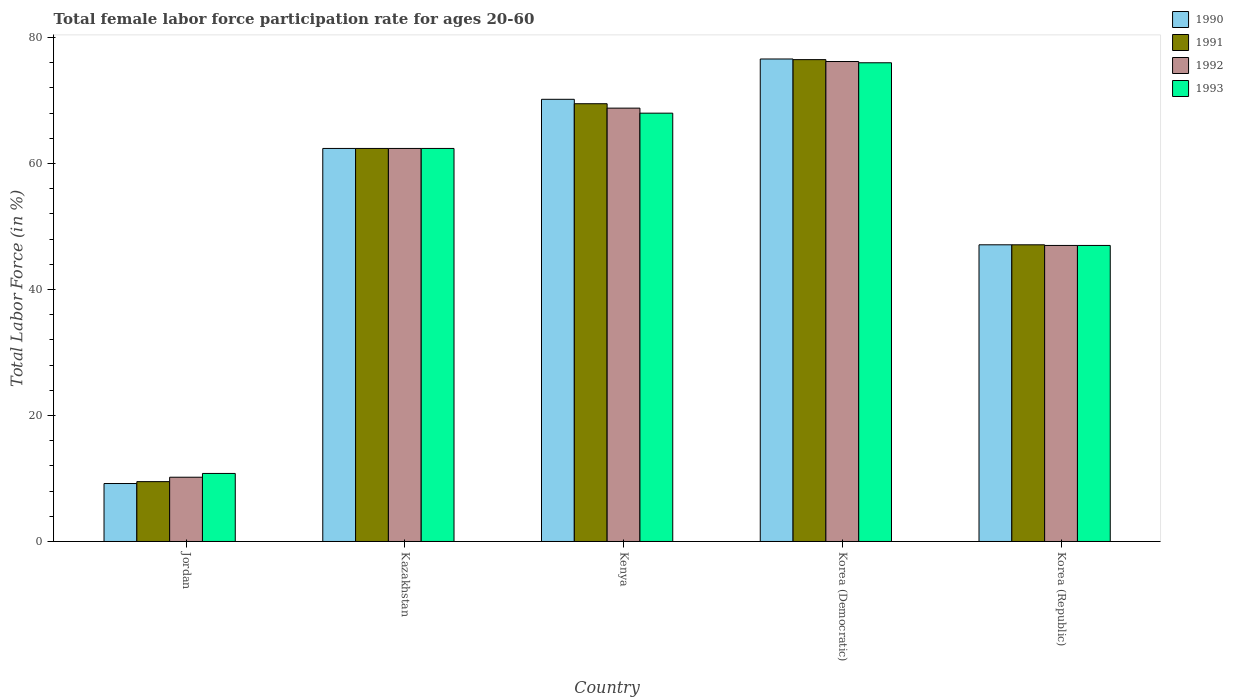How many different coloured bars are there?
Your response must be concise. 4. How many groups of bars are there?
Offer a very short reply. 5. Are the number of bars per tick equal to the number of legend labels?
Offer a terse response. Yes. Are the number of bars on each tick of the X-axis equal?
Provide a short and direct response. Yes. How many bars are there on the 1st tick from the left?
Keep it short and to the point. 4. How many bars are there on the 1st tick from the right?
Your response must be concise. 4. What is the label of the 4th group of bars from the left?
Provide a succinct answer. Korea (Democratic). What is the female labor force participation rate in 1991 in Kazakhstan?
Ensure brevity in your answer.  62.4. Across all countries, what is the maximum female labor force participation rate in 1991?
Keep it short and to the point. 76.5. Across all countries, what is the minimum female labor force participation rate in 1992?
Offer a terse response. 10.2. In which country was the female labor force participation rate in 1992 maximum?
Offer a terse response. Korea (Democratic). In which country was the female labor force participation rate in 1992 minimum?
Provide a succinct answer. Jordan. What is the total female labor force participation rate in 1993 in the graph?
Make the answer very short. 264.2. What is the difference between the female labor force participation rate in 1992 in Jordan and that in Kenya?
Offer a terse response. -58.6. What is the difference between the female labor force participation rate in 1991 in Korea (Republic) and the female labor force participation rate in 1990 in Kazakhstan?
Offer a very short reply. -15.3. What is the average female labor force participation rate in 1990 per country?
Provide a short and direct response. 53.1. What is the difference between the female labor force participation rate of/in 1990 and female labor force participation rate of/in 1991 in Jordan?
Your answer should be very brief. -0.3. What is the ratio of the female labor force participation rate in 1991 in Kenya to that in Korea (Democratic)?
Your answer should be compact. 0.91. Is the difference between the female labor force participation rate in 1990 in Jordan and Korea (Republic) greater than the difference between the female labor force participation rate in 1991 in Jordan and Korea (Republic)?
Make the answer very short. No. What is the difference between the highest and the second highest female labor force participation rate in 1991?
Ensure brevity in your answer.  7. What is the difference between the highest and the lowest female labor force participation rate in 1993?
Make the answer very short. 65.2. In how many countries, is the female labor force participation rate in 1992 greater than the average female labor force participation rate in 1992 taken over all countries?
Your answer should be compact. 3. Is it the case that in every country, the sum of the female labor force participation rate in 1992 and female labor force participation rate in 1991 is greater than the sum of female labor force participation rate in 1993 and female labor force participation rate in 1990?
Your answer should be very brief. No. What does the 2nd bar from the left in Jordan represents?
Keep it short and to the point. 1991. What does the 3rd bar from the right in Kenya represents?
Give a very brief answer. 1991. What is the difference between two consecutive major ticks on the Y-axis?
Your response must be concise. 20. Does the graph contain any zero values?
Make the answer very short. No. Does the graph contain grids?
Make the answer very short. No. How many legend labels are there?
Give a very brief answer. 4. How are the legend labels stacked?
Offer a very short reply. Vertical. What is the title of the graph?
Keep it short and to the point. Total female labor force participation rate for ages 20-60. Does "1992" appear as one of the legend labels in the graph?
Offer a terse response. Yes. What is the label or title of the Y-axis?
Provide a short and direct response. Total Labor Force (in %). What is the Total Labor Force (in %) in 1990 in Jordan?
Your answer should be very brief. 9.2. What is the Total Labor Force (in %) in 1992 in Jordan?
Your response must be concise. 10.2. What is the Total Labor Force (in %) in 1993 in Jordan?
Ensure brevity in your answer.  10.8. What is the Total Labor Force (in %) in 1990 in Kazakhstan?
Offer a very short reply. 62.4. What is the Total Labor Force (in %) of 1991 in Kazakhstan?
Keep it short and to the point. 62.4. What is the Total Labor Force (in %) in 1992 in Kazakhstan?
Provide a succinct answer. 62.4. What is the Total Labor Force (in %) in 1993 in Kazakhstan?
Your response must be concise. 62.4. What is the Total Labor Force (in %) in 1990 in Kenya?
Make the answer very short. 70.2. What is the Total Labor Force (in %) of 1991 in Kenya?
Your answer should be compact. 69.5. What is the Total Labor Force (in %) in 1992 in Kenya?
Provide a succinct answer. 68.8. What is the Total Labor Force (in %) in 1990 in Korea (Democratic)?
Ensure brevity in your answer.  76.6. What is the Total Labor Force (in %) of 1991 in Korea (Democratic)?
Offer a terse response. 76.5. What is the Total Labor Force (in %) in 1992 in Korea (Democratic)?
Give a very brief answer. 76.2. What is the Total Labor Force (in %) of 1993 in Korea (Democratic)?
Give a very brief answer. 76. What is the Total Labor Force (in %) of 1990 in Korea (Republic)?
Offer a terse response. 47.1. What is the Total Labor Force (in %) of 1991 in Korea (Republic)?
Offer a terse response. 47.1. Across all countries, what is the maximum Total Labor Force (in %) of 1990?
Provide a short and direct response. 76.6. Across all countries, what is the maximum Total Labor Force (in %) of 1991?
Give a very brief answer. 76.5. Across all countries, what is the maximum Total Labor Force (in %) of 1992?
Give a very brief answer. 76.2. Across all countries, what is the maximum Total Labor Force (in %) of 1993?
Your answer should be very brief. 76. Across all countries, what is the minimum Total Labor Force (in %) of 1990?
Your response must be concise. 9.2. Across all countries, what is the minimum Total Labor Force (in %) in 1992?
Your answer should be compact. 10.2. Across all countries, what is the minimum Total Labor Force (in %) of 1993?
Provide a succinct answer. 10.8. What is the total Total Labor Force (in %) of 1990 in the graph?
Provide a succinct answer. 265.5. What is the total Total Labor Force (in %) in 1991 in the graph?
Your answer should be very brief. 265. What is the total Total Labor Force (in %) in 1992 in the graph?
Your response must be concise. 264.6. What is the total Total Labor Force (in %) in 1993 in the graph?
Offer a very short reply. 264.2. What is the difference between the Total Labor Force (in %) in 1990 in Jordan and that in Kazakhstan?
Your answer should be very brief. -53.2. What is the difference between the Total Labor Force (in %) in 1991 in Jordan and that in Kazakhstan?
Your response must be concise. -52.9. What is the difference between the Total Labor Force (in %) in 1992 in Jordan and that in Kazakhstan?
Provide a short and direct response. -52.2. What is the difference between the Total Labor Force (in %) of 1993 in Jordan and that in Kazakhstan?
Keep it short and to the point. -51.6. What is the difference between the Total Labor Force (in %) in 1990 in Jordan and that in Kenya?
Give a very brief answer. -61. What is the difference between the Total Labor Force (in %) in 1991 in Jordan and that in Kenya?
Provide a short and direct response. -60. What is the difference between the Total Labor Force (in %) of 1992 in Jordan and that in Kenya?
Your answer should be compact. -58.6. What is the difference between the Total Labor Force (in %) of 1993 in Jordan and that in Kenya?
Your answer should be very brief. -57.2. What is the difference between the Total Labor Force (in %) in 1990 in Jordan and that in Korea (Democratic)?
Offer a terse response. -67.4. What is the difference between the Total Labor Force (in %) of 1991 in Jordan and that in Korea (Democratic)?
Your answer should be very brief. -67. What is the difference between the Total Labor Force (in %) in 1992 in Jordan and that in Korea (Democratic)?
Provide a succinct answer. -66. What is the difference between the Total Labor Force (in %) in 1993 in Jordan and that in Korea (Democratic)?
Give a very brief answer. -65.2. What is the difference between the Total Labor Force (in %) of 1990 in Jordan and that in Korea (Republic)?
Provide a short and direct response. -37.9. What is the difference between the Total Labor Force (in %) of 1991 in Jordan and that in Korea (Republic)?
Ensure brevity in your answer.  -37.6. What is the difference between the Total Labor Force (in %) of 1992 in Jordan and that in Korea (Republic)?
Make the answer very short. -36.8. What is the difference between the Total Labor Force (in %) of 1993 in Jordan and that in Korea (Republic)?
Provide a short and direct response. -36.2. What is the difference between the Total Labor Force (in %) of 1993 in Kazakhstan and that in Kenya?
Make the answer very short. -5.6. What is the difference between the Total Labor Force (in %) of 1991 in Kazakhstan and that in Korea (Democratic)?
Offer a very short reply. -14.1. What is the difference between the Total Labor Force (in %) in 1992 in Kazakhstan and that in Korea (Democratic)?
Give a very brief answer. -13.8. What is the difference between the Total Labor Force (in %) in 1993 in Kazakhstan and that in Korea (Democratic)?
Offer a very short reply. -13.6. What is the difference between the Total Labor Force (in %) in 1990 in Kazakhstan and that in Korea (Republic)?
Give a very brief answer. 15.3. What is the difference between the Total Labor Force (in %) of 1993 in Kazakhstan and that in Korea (Republic)?
Give a very brief answer. 15.4. What is the difference between the Total Labor Force (in %) of 1990 in Kenya and that in Korea (Democratic)?
Your answer should be very brief. -6.4. What is the difference between the Total Labor Force (in %) of 1993 in Kenya and that in Korea (Democratic)?
Give a very brief answer. -8. What is the difference between the Total Labor Force (in %) in 1990 in Kenya and that in Korea (Republic)?
Provide a short and direct response. 23.1. What is the difference between the Total Labor Force (in %) of 1991 in Kenya and that in Korea (Republic)?
Provide a short and direct response. 22.4. What is the difference between the Total Labor Force (in %) in 1992 in Kenya and that in Korea (Republic)?
Your answer should be compact. 21.8. What is the difference between the Total Labor Force (in %) in 1990 in Korea (Democratic) and that in Korea (Republic)?
Make the answer very short. 29.5. What is the difference between the Total Labor Force (in %) in 1991 in Korea (Democratic) and that in Korea (Republic)?
Provide a succinct answer. 29.4. What is the difference between the Total Labor Force (in %) of 1992 in Korea (Democratic) and that in Korea (Republic)?
Your response must be concise. 29.2. What is the difference between the Total Labor Force (in %) of 1993 in Korea (Democratic) and that in Korea (Republic)?
Provide a succinct answer. 29. What is the difference between the Total Labor Force (in %) in 1990 in Jordan and the Total Labor Force (in %) in 1991 in Kazakhstan?
Keep it short and to the point. -53.2. What is the difference between the Total Labor Force (in %) of 1990 in Jordan and the Total Labor Force (in %) of 1992 in Kazakhstan?
Make the answer very short. -53.2. What is the difference between the Total Labor Force (in %) in 1990 in Jordan and the Total Labor Force (in %) in 1993 in Kazakhstan?
Offer a terse response. -53.2. What is the difference between the Total Labor Force (in %) in 1991 in Jordan and the Total Labor Force (in %) in 1992 in Kazakhstan?
Provide a short and direct response. -52.9. What is the difference between the Total Labor Force (in %) in 1991 in Jordan and the Total Labor Force (in %) in 1993 in Kazakhstan?
Provide a short and direct response. -52.9. What is the difference between the Total Labor Force (in %) of 1992 in Jordan and the Total Labor Force (in %) of 1993 in Kazakhstan?
Give a very brief answer. -52.2. What is the difference between the Total Labor Force (in %) in 1990 in Jordan and the Total Labor Force (in %) in 1991 in Kenya?
Make the answer very short. -60.3. What is the difference between the Total Labor Force (in %) in 1990 in Jordan and the Total Labor Force (in %) in 1992 in Kenya?
Offer a terse response. -59.6. What is the difference between the Total Labor Force (in %) of 1990 in Jordan and the Total Labor Force (in %) of 1993 in Kenya?
Provide a short and direct response. -58.8. What is the difference between the Total Labor Force (in %) in 1991 in Jordan and the Total Labor Force (in %) in 1992 in Kenya?
Your answer should be very brief. -59.3. What is the difference between the Total Labor Force (in %) of 1991 in Jordan and the Total Labor Force (in %) of 1993 in Kenya?
Provide a succinct answer. -58.5. What is the difference between the Total Labor Force (in %) of 1992 in Jordan and the Total Labor Force (in %) of 1993 in Kenya?
Make the answer very short. -57.8. What is the difference between the Total Labor Force (in %) of 1990 in Jordan and the Total Labor Force (in %) of 1991 in Korea (Democratic)?
Ensure brevity in your answer.  -67.3. What is the difference between the Total Labor Force (in %) of 1990 in Jordan and the Total Labor Force (in %) of 1992 in Korea (Democratic)?
Keep it short and to the point. -67. What is the difference between the Total Labor Force (in %) in 1990 in Jordan and the Total Labor Force (in %) in 1993 in Korea (Democratic)?
Provide a succinct answer. -66.8. What is the difference between the Total Labor Force (in %) of 1991 in Jordan and the Total Labor Force (in %) of 1992 in Korea (Democratic)?
Offer a very short reply. -66.7. What is the difference between the Total Labor Force (in %) in 1991 in Jordan and the Total Labor Force (in %) in 1993 in Korea (Democratic)?
Give a very brief answer. -66.5. What is the difference between the Total Labor Force (in %) of 1992 in Jordan and the Total Labor Force (in %) of 1993 in Korea (Democratic)?
Your answer should be very brief. -65.8. What is the difference between the Total Labor Force (in %) of 1990 in Jordan and the Total Labor Force (in %) of 1991 in Korea (Republic)?
Your answer should be compact. -37.9. What is the difference between the Total Labor Force (in %) of 1990 in Jordan and the Total Labor Force (in %) of 1992 in Korea (Republic)?
Keep it short and to the point. -37.8. What is the difference between the Total Labor Force (in %) in 1990 in Jordan and the Total Labor Force (in %) in 1993 in Korea (Republic)?
Make the answer very short. -37.8. What is the difference between the Total Labor Force (in %) in 1991 in Jordan and the Total Labor Force (in %) in 1992 in Korea (Republic)?
Give a very brief answer. -37.5. What is the difference between the Total Labor Force (in %) in 1991 in Jordan and the Total Labor Force (in %) in 1993 in Korea (Republic)?
Provide a succinct answer. -37.5. What is the difference between the Total Labor Force (in %) in 1992 in Jordan and the Total Labor Force (in %) in 1993 in Korea (Republic)?
Your response must be concise. -36.8. What is the difference between the Total Labor Force (in %) of 1990 in Kazakhstan and the Total Labor Force (in %) of 1992 in Kenya?
Ensure brevity in your answer.  -6.4. What is the difference between the Total Labor Force (in %) of 1991 in Kazakhstan and the Total Labor Force (in %) of 1992 in Kenya?
Ensure brevity in your answer.  -6.4. What is the difference between the Total Labor Force (in %) in 1991 in Kazakhstan and the Total Labor Force (in %) in 1993 in Kenya?
Provide a short and direct response. -5.6. What is the difference between the Total Labor Force (in %) in 1992 in Kazakhstan and the Total Labor Force (in %) in 1993 in Kenya?
Ensure brevity in your answer.  -5.6. What is the difference between the Total Labor Force (in %) of 1990 in Kazakhstan and the Total Labor Force (in %) of 1991 in Korea (Democratic)?
Make the answer very short. -14.1. What is the difference between the Total Labor Force (in %) of 1991 in Kazakhstan and the Total Labor Force (in %) of 1993 in Korea (Democratic)?
Your response must be concise. -13.6. What is the difference between the Total Labor Force (in %) in 1990 in Kazakhstan and the Total Labor Force (in %) in 1991 in Korea (Republic)?
Give a very brief answer. 15.3. What is the difference between the Total Labor Force (in %) of 1992 in Kazakhstan and the Total Labor Force (in %) of 1993 in Korea (Republic)?
Your answer should be compact. 15.4. What is the difference between the Total Labor Force (in %) in 1990 in Kenya and the Total Labor Force (in %) in 1991 in Korea (Democratic)?
Provide a succinct answer. -6.3. What is the difference between the Total Labor Force (in %) of 1990 in Kenya and the Total Labor Force (in %) of 1992 in Korea (Democratic)?
Your answer should be compact. -6. What is the difference between the Total Labor Force (in %) of 1991 in Kenya and the Total Labor Force (in %) of 1992 in Korea (Democratic)?
Your answer should be very brief. -6.7. What is the difference between the Total Labor Force (in %) of 1992 in Kenya and the Total Labor Force (in %) of 1993 in Korea (Democratic)?
Your response must be concise. -7.2. What is the difference between the Total Labor Force (in %) in 1990 in Kenya and the Total Labor Force (in %) in 1991 in Korea (Republic)?
Offer a terse response. 23.1. What is the difference between the Total Labor Force (in %) in 1990 in Kenya and the Total Labor Force (in %) in 1992 in Korea (Republic)?
Your response must be concise. 23.2. What is the difference between the Total Labor Force (in %) in 1990 in Kenya and the Total Labor Force (in %) in 1993 in Korea (Republic)?
Ensure brevity in your answer.  23.2. What is the difference between the Total Labor Force (in %) of 1991 in Kenya and the Total Labor Force (in %) of 1992 in Korea (Republic)?
Make the answer very short. 22.5. What is the difference between the Total Labor Force (in %) in 1991 in Kenya and the Total Labor Force (in %) in 1993 in Korea (Republic)?
Ensure brevity in your answer.  22.5. What is the difference between the Total Labor Force (in %) in 1992 in Kenya and the Total Labor Force (in %) in 1993 in Korea (Republic)?
Give a very brief answer. 21.8. What is the difference between the Total Labor Force (in %) of 1990 in Korea (Democratic) and the Total Labor Force (in %) of 1991 in Korea (Republic)?
Offer a very short reply. 29.5. What is the difference between the Total Labor Force (in %) in 1990 in Korea (Democratic) and the Total Labor Force (in %) in 1992 in Korea (Republic)?
Ensure brevity in your answer.  29.6. What is the difference between the Total Labor Force (in %) of 1990 in Korea (Democratic) and the Total Labor Force (in %) of 1993 in Korea (Republic)?
Provide a succinct answer. 29.6. What is the difference between the Total Labor Force (in %) of 1991 in Korea (Democratic) and the Total Labor Force (in %) of 1992 in Korea (Republic)?
Ensure brevity in your answer.  29.5. What is the difference between the Total Labor Force (in %) of 1991 in Korea (Democratic) and the Total Labor Force (in %) of 1993 in Korea (Republic)?
Provide a succinct answer. 29.5. What is the difference between the Total Labor Force (in %) in 1992 in Korea (Democratic) and the Total Labor Force (in %) in 1993 in Korea (Republic)?
Your answer should be very brief. 29.2. What is the average Total Labor Force (in %) in 1990 per country?
Ensure brevity in your answer.  53.1. What is the average Total Labor Force (in %) of 1991 per country?
Give a very brief answer. 53. What is the average Total Labor Force (in %) in 1992 per country?
Make the answer very short. 52.92. What is the average Total Labor Force (in %) in 1993 per country?
Provide a succinct answer. 52.84. What is the difference between the Total Labor Force (in %) of 1990 and Total Labor Force (in %) of 1992 in Jordan?
Ensure brevity in your answer.  -1. What is the difference between the Total Labor Force (in %) of 1990 and Total Labor Force (in %) of 1993 in Jordan?
Ensure brevity in your answer.  -1.6. What is the difference between the Total Labor Force (in %) in 1991 and Total Labor Force (in %) in 1992 in Jordan?
Offer a terse response. -0.7. What is the difference between the Total Labor Force (in %) in 1990 and Total Labor Force (in %) in 1991 in Kazakhstan?
Your answer should be compact. 0. What is the difference between the Total Labor Force (in %) of 1990 and Total Labor Force (in %) of 1992 in Kazakhstan?
Your answer should be compact. 0. What is the difference between the Total Labor Force (in %) in 1991 and Total Labor Force (in %) in 1992 in Kazakhstan?
Provide a succinct answer. 0. What is the difference between the Total Labor Force (in %) in 1991 and Total Labor Force (in %) in 1993 in Kazakhstan?
Give a very brief answer. 0. What is the difference between the Total Labor Force (in %) in 1992 and Total Labor Force (in %) in 1993 in Kazakhstan?
Your answer should be compact. 0. What is the difference between the Total Labor Force (in %) in 1990 and Total Labor Force (in %) in 1993 in Kenya?
Offer a terse response. 2.2. What is the difference between the Total Labor Force (in %) in 1991 and Total Labor Force (in %) in 1992 in Kenya?
Offer a very short reply. 0.7. What is the difference between the Total Labor Force (in %) of 1990 and Total Labor Force (in %) of 1992 in Korea (Democratic)?
Give a very brief answer. 0.4. What is the difference between the Total Labor Force (in %) of 1991 and Total Labor Force (in %) of 1993 in Korea (Democratic)?
Provide a short and direct response. 0.5. What is the difference between the Total Labor Force (in %) in 1990 and Total Labor Force (in %) in 1991 in Korea (Republic)?
Provide a succinct answer. 0. What is the difference between the Total Labor Force (in %) of 1990 and Total Labor Force (in %) of 1993 in Korea (Republic)?
Ensure brevity in your answer.  0.1. What is the difference between the Total Labor Force (in %) in 1991 and Total Labor Force (in %) in 1992 in Korea (Republic)?
Offer a very short reply. 0.1. What is the difference between the Total Labor Force (in %) in 1991 and Total Labor Force (in %) in 1993 in Korea (Republic)?
Ensure brevity in your answer.  0.1. What is the difference between the Total Labor Force (in %) of 1992 and Total Labor Force (in %) of 1993 in Korea (Republic)?
Offer a very short reply. 0. What is the ratio of the Total Labor Force (in %) of 1990 in Jordan to that in Kazakhstan?
Offer a terse response. 0.15. What is the ratio of the Total Labor Force (in %) of 1991 in Jordan to that in Kazakhstan?
Give a very brief answer. 0.15. What is the ratio of the Total Labor Force (in %) of 1992 in Jordan to that in Kazakhstan?
Keep it short and to the point. 0.16. What is the ratio of the Total Labor Force (in %) of 1993 in Jordan to that in Kazakhstan?
Ensure brevity in your answer.  0.17. What is the ratio of the Total Labor Force (in %) of 1990 in Jordan to that in Kenya?
Offer a very short reply. 0.13. What is the ratio of the Total Labor Force (in %) in 1991 in Jordan to that in Kenya?
Make the answer very short. 0.14. What is the ratio of the Total Labor Force (in %) of 1992 in Jordan to that in Kenya?
Ensure brevity in your answer.  0.15. What is the ratio of the Total Labor Force (in %) in 1993 in Jordan to that in Kenya?
Provide a succinct answer. 0.16. What is the ratio of the Total Labor Force (in %) of 1990 in Jordan to that in Korea (Democratic)?
Offer a terse response. 0.12. What is the ratio of the Total Labor Force (in %) in 1991 in Jordan to that in Korea (Democratic)?
Ensure brevity in your answer.  0.12. What is the ratio of the Total Labor Force (in %) in 1992 in Jordan to that in Korea (Democratic)?
Provide a succinct answer. 0.13. What is the ratio of the Total Labor Force (in %) of 1993 in Jordan to that in Korea (Democratic)?
Offer a very short reply. 0.14. What is the ratio of the Total Labor Force (in %) of 1990 in Jordan to that in Korea (Republic)?
Provide a short and direct response. 0.2. What is the ratio of the Total Labor Force (in %) in 1991 in Jordan to that in Korea (Republic)?
Provide a short and direct response. 0.2. What is the ratio of the Total Labor Force (in %) in 1992 in Jordan to that in Korea (Republic)?
Make the answer very short. 0.22. What is the ratio of the Total Labor Force (in %) of 1993 in Jordan to that in Korea (Republic)?
Make the answer very short. 0.23. What is the ratio of the Total Labor Force (in %) in 1991 in Kazakhstan to that in Kenya?
Your answer should be compact. 0.9. What is the ratio of the Total Labor Force (in %) of 1992 in Kazakhstan to that in Kenya?
Keep it short and to the point. 0.91. What is the ratio of the Total Labor Force (in %) in 1993 in Kazakhstan to that in Kenya?
Offer a terse response. 0.92. What is the ratio of the Total Labor Force (in %) in 1990 in Kazakhstan to that in Korea (Democratic)?
Ensure brevity in your answer.  0.81. What is the ratio of the Total Labor Force (in %) of 1991 in Kazakhstan to that in Korea (Democratic)?
Ensure brevity in your answer.  0.82. What is the ratio of the Total Labor Force (in %) in 1992 in Kazakhstan to that in Korea (Democratic)?
Make the answer very short. 0.82. What is the ratio of the Total Labor Force (in %) in 1993 in Kazakhstan to that in Korea (Democratic)?
Your answer should be very brief. 0.82. What is the ratio of the Total Labor Force (in %) in 1990 in Kazakhstan to that in Korea (Republic)?
Ensure brevity in your answer.  1.32. What is the ratio of the Total Labor Force (in %) in 1991 in Kazakhstan to that in Korea (Republic)?
Make the answer very short. 1.32. What is the ratio of the Total Labor Force (in %) in 1992 in Kazakhstan to that in Korea (Republic)?
Ensure brevity in your answer.  1.33. What is the ratio of the Total Labor Force (in %) in 1993 in Kazakhstan to that in Korea (Republic)?
Your answer should be very brief. 1.33. What is the ratio of the Total Labor Force (in %) of 1990 in Kenya to that in Korea (Democratic)?
Your answer should be compact. 0.92. What is the ratio of the Total Labor Force (in %) of 1991 in Kenya to that in Korea (Democratic)?
Keep it short and to the point. 0.91. What is the ratio of the Total Labor Force (in %) of 1992 in Kenya to that in Korea (Democratic)?
Keep it short and to the point. 0.9. What is the ratio of the Total Labor Force (in %) in 1993 in Kenya to that in Korea (Democratic)?
Make the answer very short. 0.89. What is the ratio of the Total Labor Force (in %) of 1990 in Kenya to that in Korea (Republic)?
Provide a succinct answer. 1.49. What is the ratio of the Total Labor Force (in %) of 1991 in Kenya to that in Korea (Republic)?
Give a very brief answer. 1.48. What is the ratio of the Total Labor Force (in %) in 1992 in Kenya to that in Korea (Republic)?
Provide a succinct answer. 1.46. What is the ratio of the Total Labor Force (in %) in 1993 in Kenya to that in Korea (Republic)?
Offer a terse response. 1.45. What is the ratio of the Total Labor Force (in %) in 1990 in Korea (Democratic) to that in Korea (Republic)?
Give a very brief answer. 1.63. What is the ratio of the Total Labor Force (in %) of 1991 in Korea (Democratic) to that in Korea (Republic)?
Your response must be concise. 1.62. What is the ratio of the Total Labor Force (in %) in 1992 in Korea (Democratic) to that in Korea (Republic)?
Your answer should be very brief. 1.62. What is the ratio of the Total Labor Force (in %) of 1993 in Korea (Democratic) to that in Korea (Republic)?
Offer a terse response. 1.62. What is the difference between the highest and the second highest Total Labor Force (in %) of 1991?
Offer a very short reply. 7. What is the difference between the highest and the second highest Total Labor Force (in %) in 1992?
Offer a terse response. 7.4. What is the difference between the highest and the lowest Total Labor Force (in %) of 1990?
Keep it short and to the point. 67.4. What is the difference between the highest and the lowest Total Labor Force (in %) of 1991?
Give a very brief answer. 67. What is the difference between the highest and the lowest Total Labor Force (in %) in 1993?
Keep it short and to the point. 65.2. 